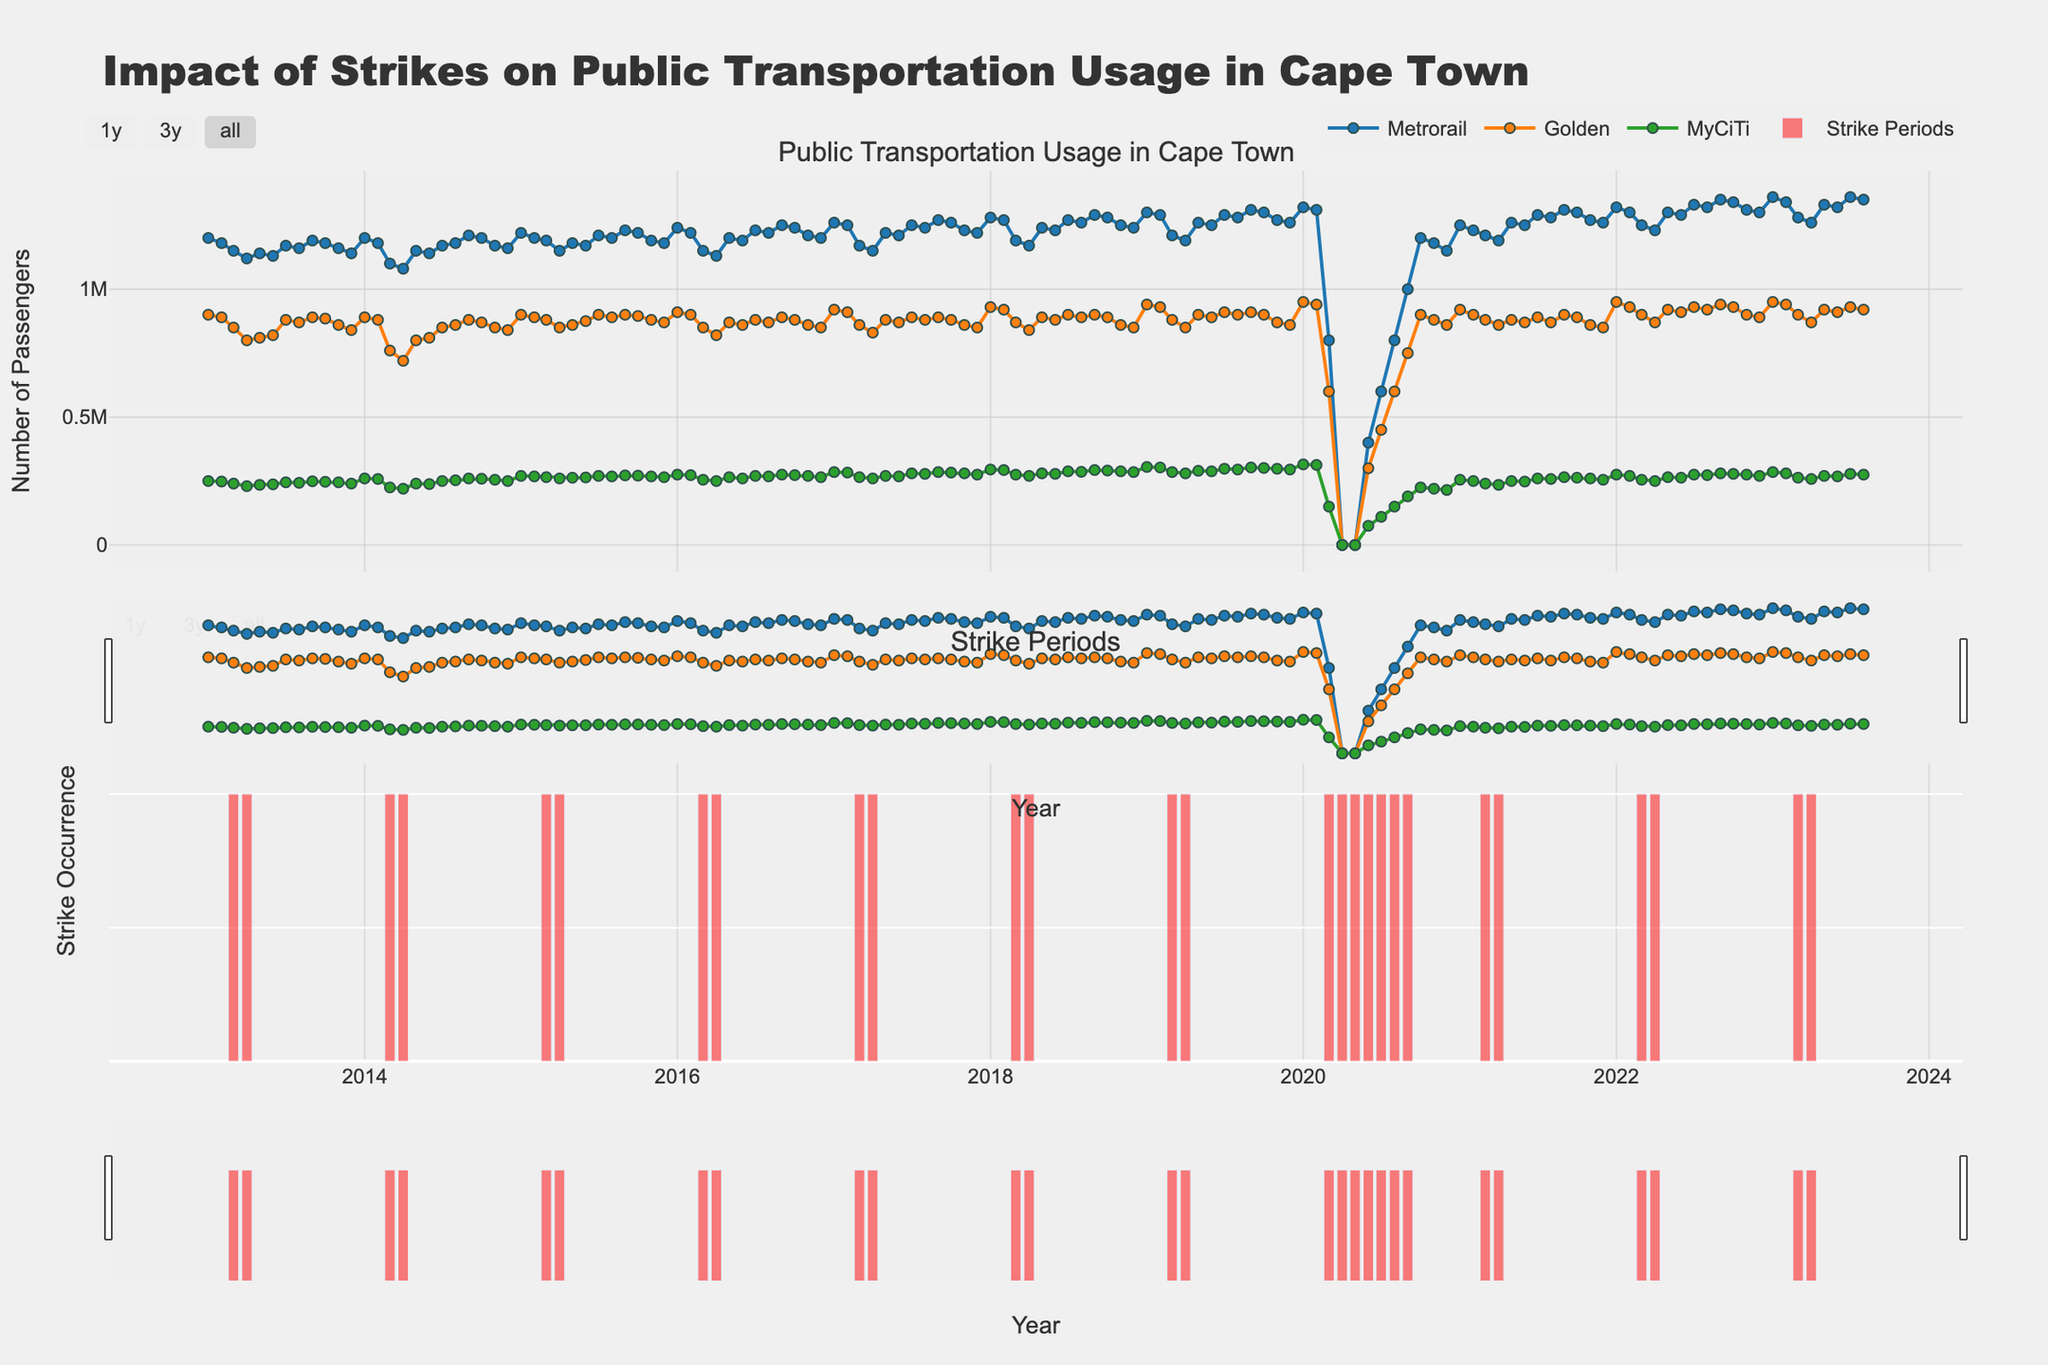What is the title of the figure? The title of the figure is located at the top, serving as an overview of the content.
Answer: "Impact of Strikes on Public Transportation Usage in Cape Town" How does the number of Metrorail passengers in March 2023 compare to March 2022? Identify the passenger counts for Metrorail in March 2023 and March 2022 and compare them. In March 2022, the count is 1,250,000, while in March 2023, it's 1,280,000.
Answer: Higher in March 2023 Which month and year show the lowest Metrorail passenger count, and what is the count? Locate the minimum value on the Metrorail line and read the corresponding month and year. This occurs in April 2020, with a count of 0.
Answer: April 2020, 0 How did the strikes in 2020 impact Golden Arrow passenger numbers in April compared to the previous month? Compare the number of passengers in March 2020 (600,000) and April 2020 (0).
Answer: Significant decrease Which mode of transportation saw the least number of passengers during April 2020? Compare passenger counts among Metrorail, Golden Arrow, and MyCiTi for April 2020. All modes had 0 passengers in April 2020.
Answer: All had 0 passengers How does the trend for MyCiTi passengers appear to change during strike periods compared to non-strike periods? Observe MyCiTi passenger counts during strike periods vs. non-strike periods. During strikes, lower counts are evident.
Answer: Decreases during strikes What was the trend in Metrorail passenger numbers from January 2019 to August 2019? Follow the Metrorail passenger line from January to August 2019, observing changes from 1,300,000 in January to 1,280,000 in August.
Answer: Initial increase, then slight decline How does the total number of passengers for all transport modes in January 2022 compare to January 2023? Sum up passengers for each transport mode in January 2022 (Metrorail: 1,320,000; Golden Arrow: 950,000; MyCiTi: 275,000) and January 2023 (Metrorail: 1,360,000; Golden Arrow: 950,000; MyCiTi: 285,000), then compare. January 2022 total: 2,545,000. January 2023 total: 2,595,000.
Answer: Higher in January 2023 What was the biggest drop in passenger numbers for Golden Arrow during a strike period and when did it occur? Look for the largest single-month drop in Golden Arrow passengers during strike periods. From February 2014 (880,000) to March 2014 (760,000), there is a drop of 120,000.
Answer: March 2014 Did the number of MyCiTi passengers during strike periods ever reach 300,000? Inspect the MyCiTi line during strike periods and check if it ever reaches 300,000 passengers; it does not.
Answer: No 